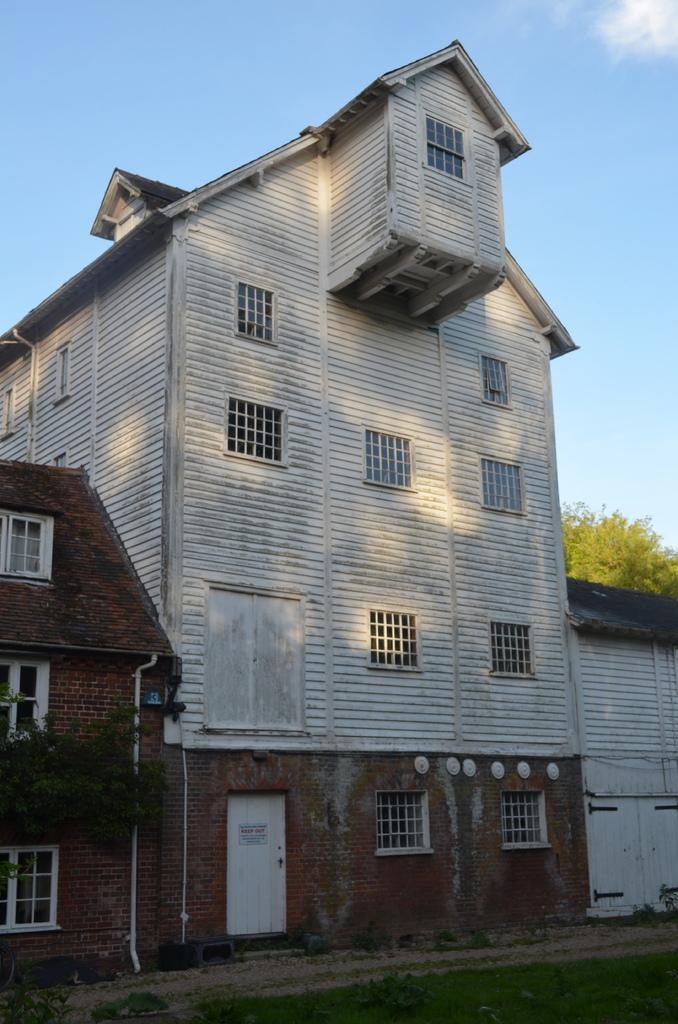What type of structures are present in the image? There are buildings in the image. What architectural features can be seen on the buildings? There are windows and a door visible on the buildings. What type of vegetation is present in the image? There is a tree in the image. What part of the natural environment is visible in the image? The sky is visible in the image. What type of nation is depicted in the image? There is no specific nation depicted in the image; it features buildings, windows, a door, a tree, and the sky. Can you tell me how many wrens are perched on the tree in the image? There are no wrens present in the image; it only features a tree. What type of calculator is visible on the door in the image? There is no calculator visible on the door in the image; it only features a door. 